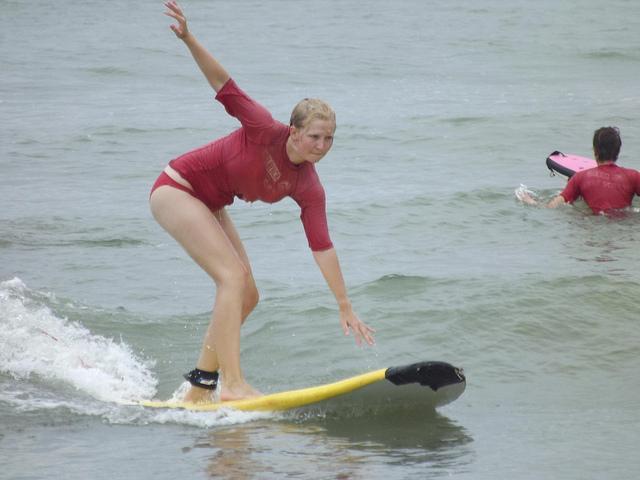How many people are visible?
Give a very brief answer. 2. How many giraffe are in the photo?
Give a very brief answer. 0. 